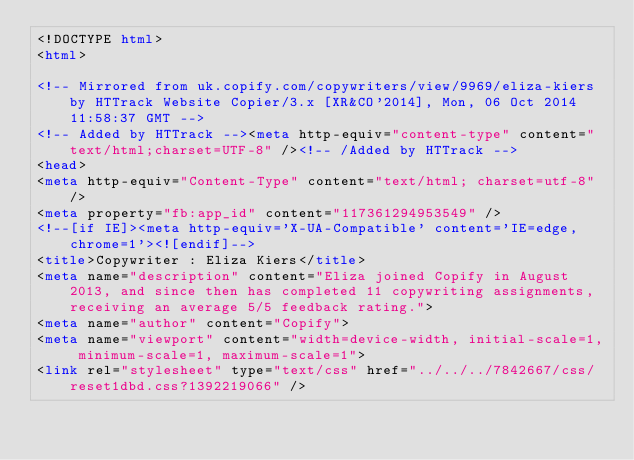<code> <loc_0><loc_0><loc_500><loc_500><_HTML_><!DOCTYPE html>
<html>

<!-- Mirrored from uk.copify.com/copywriters/view/9969/eliza-kiers by HTTrack Website Copier/3.x [XR&CO'2014], Mon, 06 Oct 2014 11:58:37 GMT -->
<!-- Added by HTTrack --><meta http-equiv="content-type" content="text/html;charset=UTF-8" /><!-- /Added by HTTrack -->
<head>
<meta http-equiv="Content-Type" content="text/html; charset=utf-8" />
<meta property="fb:app_id" content="117361294953549" />
<!--[if IE]><meta http-equiv='X-UA-Compatible' content='IE=edge,chrome=1'><![endif]-->
<title>Copywriter : Eliza Kiers</title>
<meta name="description" content="Eliza joined Copify in August 2013, and since then has completed 11 copywriting assignments, receiving an average 5/5 feedback rating.">
<meta name="author" content="Copify">
<meta name="viewport" content="width=device-width, initial-scale=1, minimum-scale=1, maximum-scale=1">
<link rel="stylesheet" type="text/css" href="../../../7842667/css/reset1dbd.css?1392219066" /></code> 